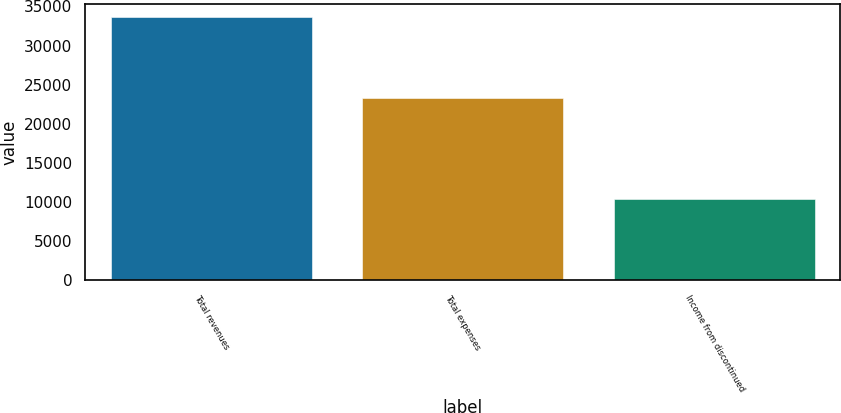Convert chart. <chart><loc_0><loc_0><loc_500><loc_500><bar_chart><fcel>Total revenues<fcel>Total expenses<fcel>Income from discontinued<nl><fcel>33612<fcel>23270<fcel>10342<nl></chart> 